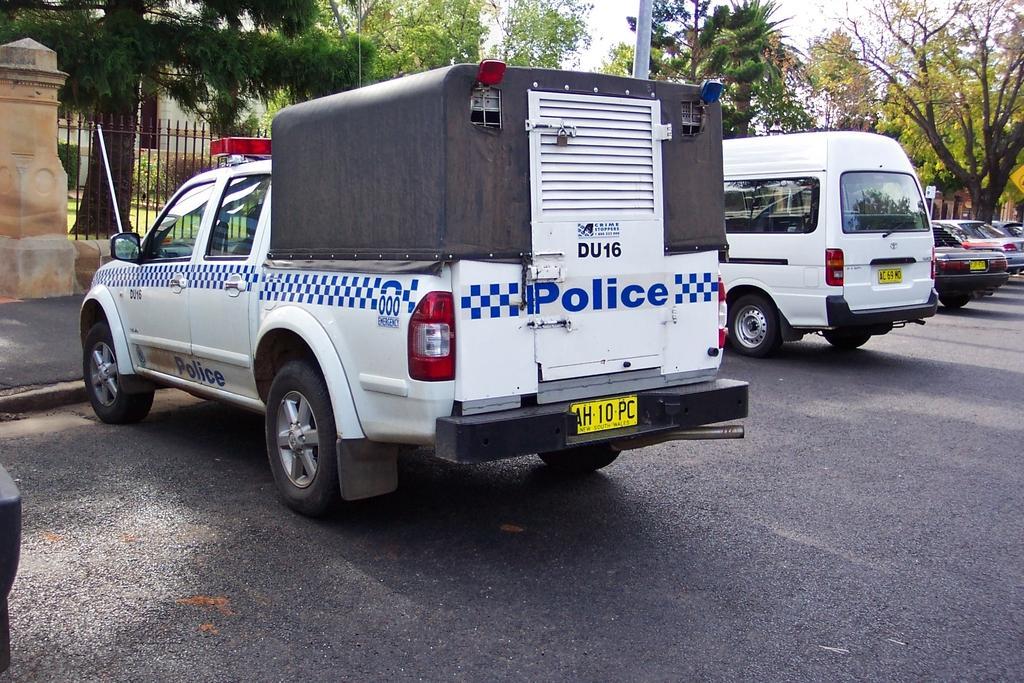Can you describe this image briefly? There are vehicles parked on the road as we can see in the middle of this image. There are trees and a building in the background. 